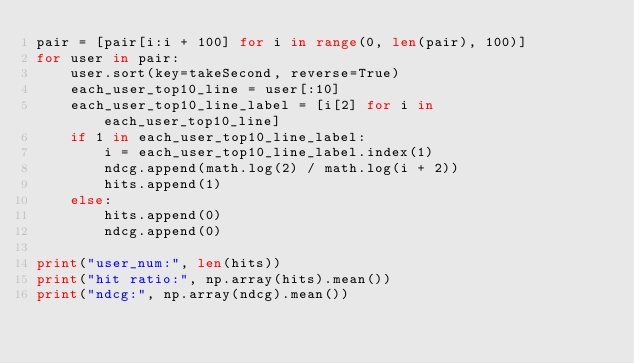<code> <loc_0><loc_0><loc_500><loc_500><_Python_>pair = [pair[i:i + 100] for i in range(0, len(pair), 100)]
for user in pair:
    user.sort(key=takeSecond, reverse=True)
    each_user_top10_line = user[:10]
    each_user_top10_line_label = [i[2] for i in each_user_top10_line]
    if 1 in each_user_top10_line_label:
        i = each_user_top10_line_label.index(1)
        ndcg.append(math.log(2) / math.log(i + 2))
        hits.append(1)
    else:
        hits.append(0)
        ndcg.append(0)

print("user_num:", len(hits))
print("hit ratio:", np.array(hits).mean())
print("ndcg:", np.array(ndcg).mean())
</code> 